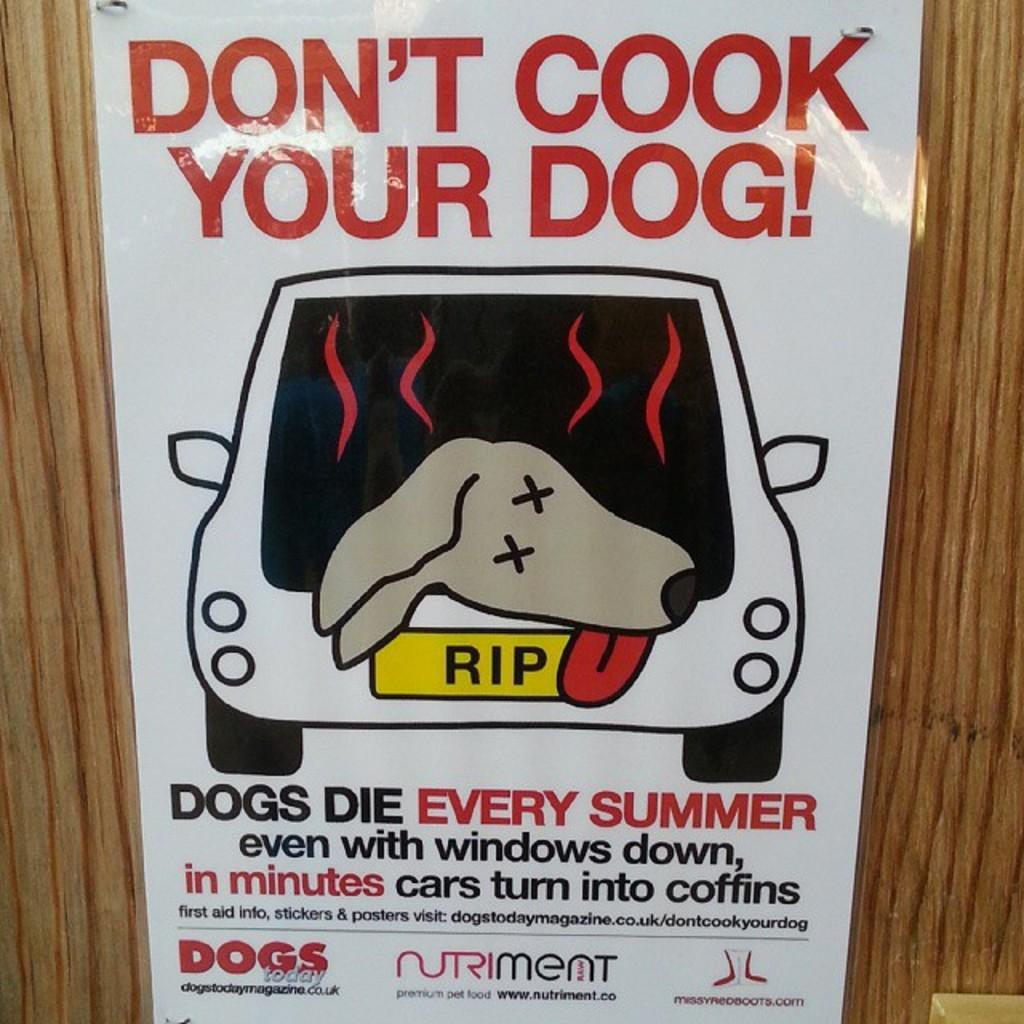What is located in the center of the image? There is a poster in the center of the image. Where is the poster placed? The poster is placed on a wall. How many babies are being held by the parent in the image? There is no parent or babies present in the image; it only features a poster on a wall. 